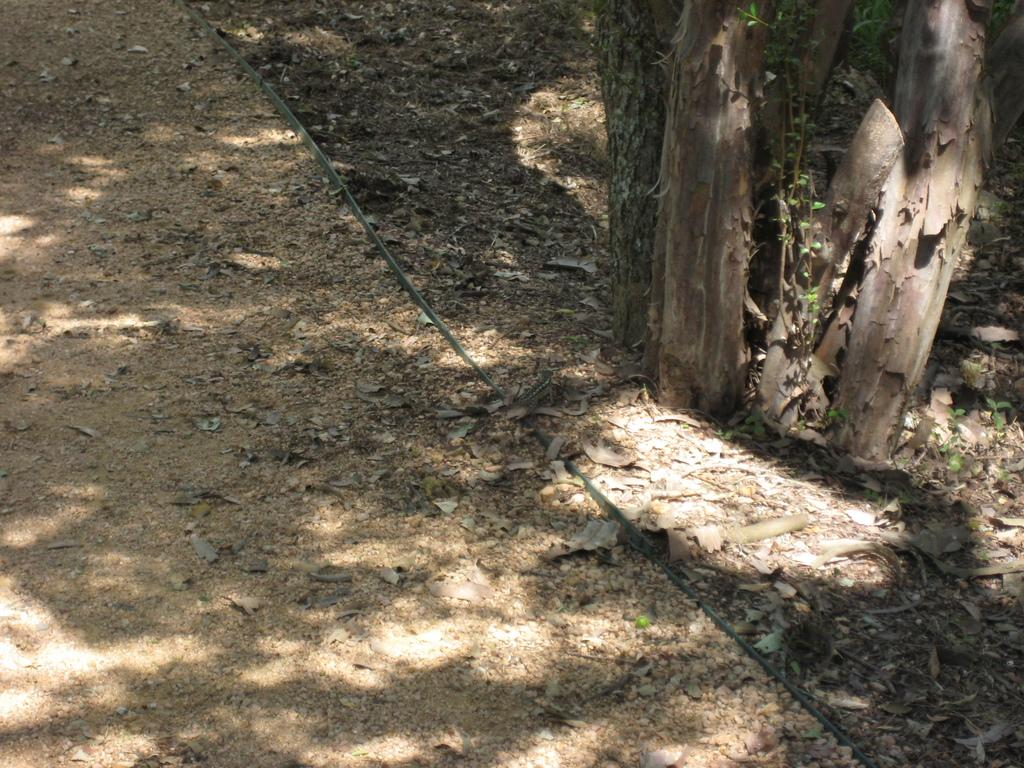What type of vegetation can be seen in the image? There are leaves in the image. What part of the tree is visible in the image? There is a tree trunk in the image. What type of curtain can be seen hanging from the tree in the image? There is no curtain present in the image; it features leaves and a tree trunk. How does the water create waves around the tree in the image? There is no water or waves present in the image; it only shows leaves and a tree trunk. 